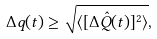Convert formula to latex. <formula><loc_0><loc_0><loc_500><loc_500>\Delta q ( t ) \geq \sqrt { \langle [ \Delta \hat { Q } ( t ) ] ^ { 2 } \rangle } ,</formula> 